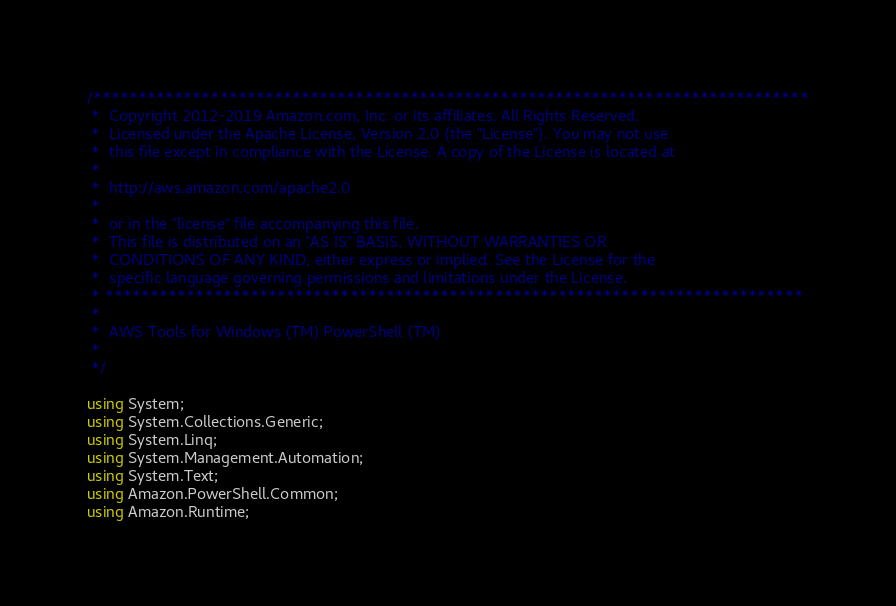<code> <loc_0><loc_0><loc_500><loc_500><_C#_>/*******************************************************************************
 *  Copyright 2012-2019 Amazon.com, Inc. or its affiliates. All Rights Reserved.
 *  Licensed under the Apache License, Version 2.0 (the "License"). You may not use
 *  this file except in compliance with the License. A copy of the License is located at
 *
 *  http://aws.amazon.com/apache2.0
 *
 *  or in the "license" file accompanying this file.
 *  This file is distributed on an "AS IS" BASIS, WITHOUT WARRANTIES OR
 *  CONDITIONS OF ANY KIND, either express or implied. See the License for the
 *  specific language governing permissions and limitations under the License.
 * *****************************************************************************
 *
 *  AWS Tools for Windows (TM) PowerShell (TM)
 *
 */

using System;
using System.Collections.Generic;
using System.Linq;
using System.Management.Automation;
using System.Text;
using Amazon.PowerShell.Common;
using Amazon.Runtime;</code> 